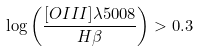<formula> <loc_0><loc_0><loc_500><loc_500>\log \left ( \frac { [ O I I I ] \lambda 5 0 0 8 } { H \beta } \right ) > 0 . 3</formula> 